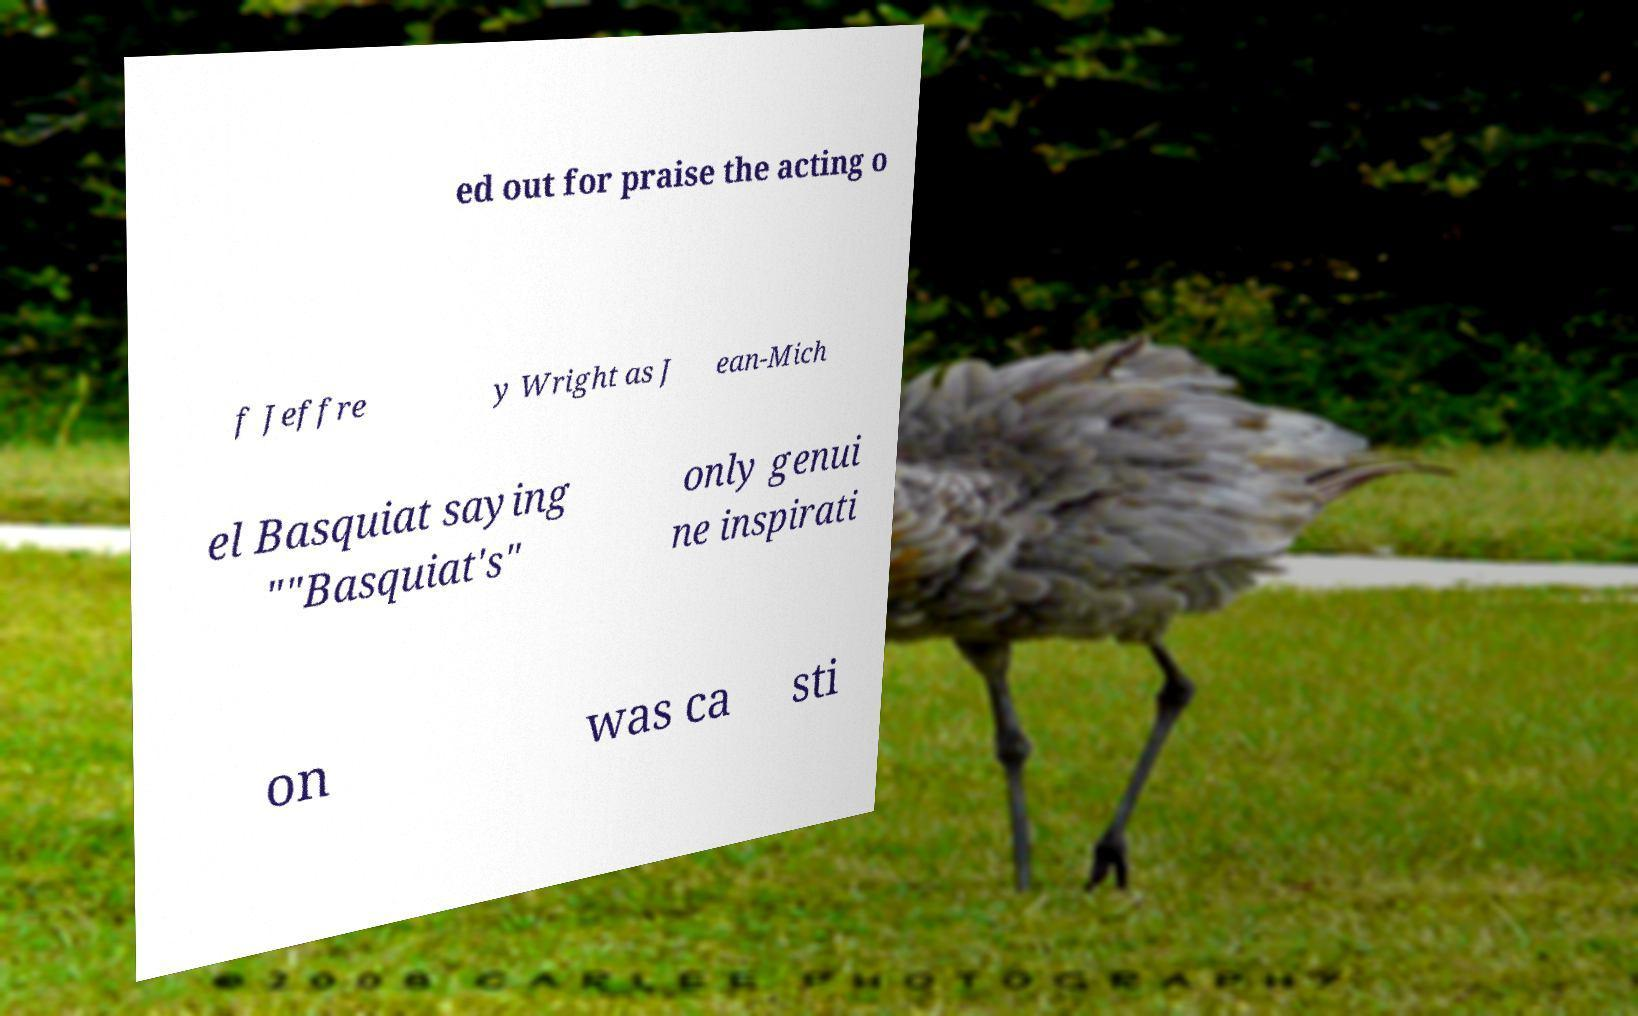I need the written content from this picture converted into text. Can you do that? ed out for praise the acting o f Jeffre y Wright as J ean-Mich el Basquiat saying ""Basquiat's" only genui ne inspirati on was ca sti 